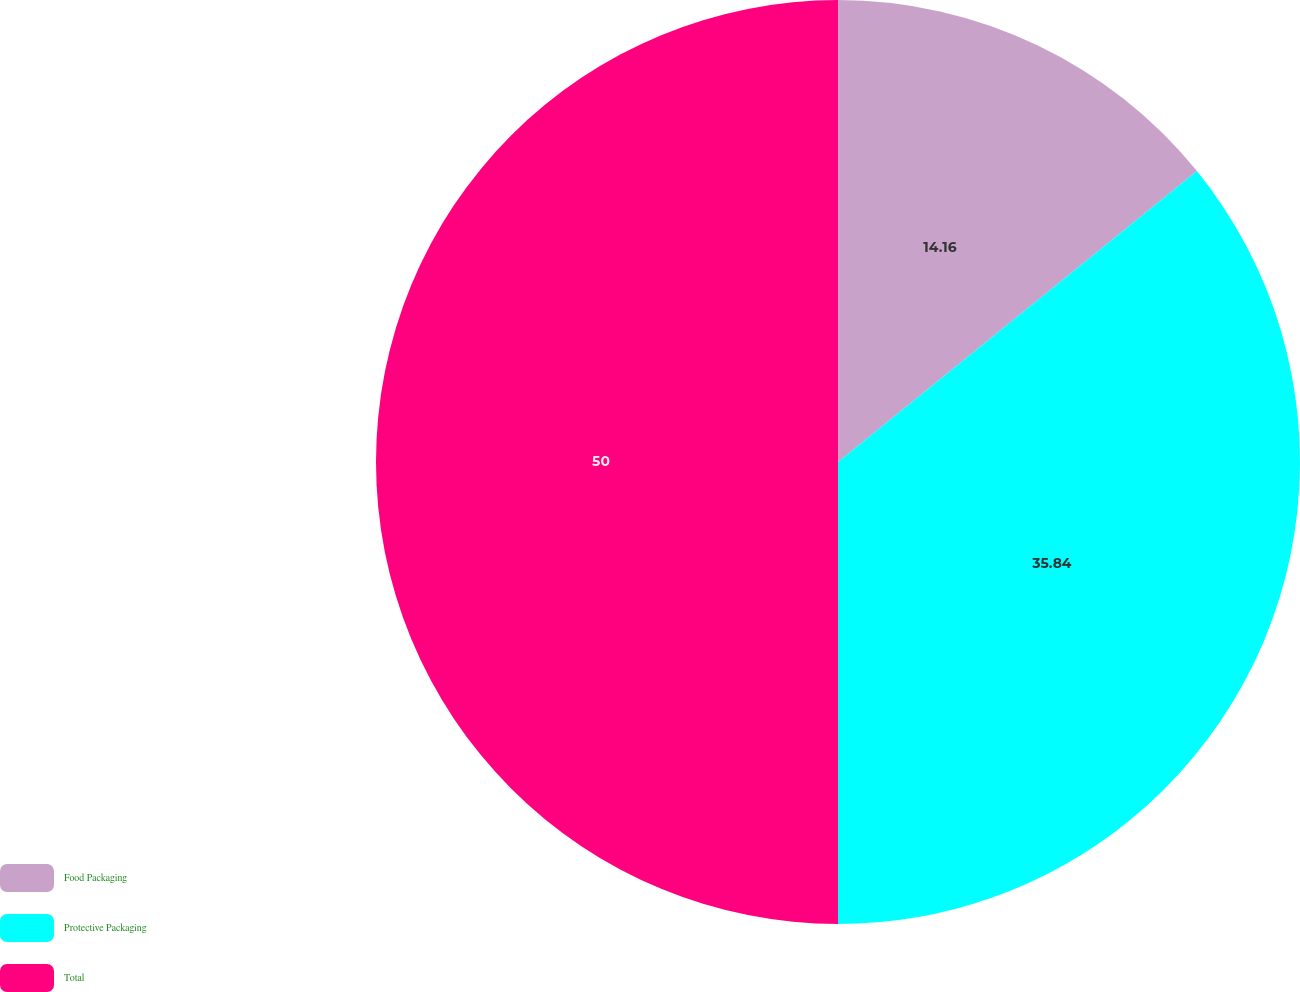<chart> <loc_0><loc_0><loc_500><loc_500><pie_chart><fcel>Food Packaging<fcel>Protective Packaging<fcel>Total<nl><fcel>14.16%<fcel>35.84%<fcel>50.0%<nl></chart> 